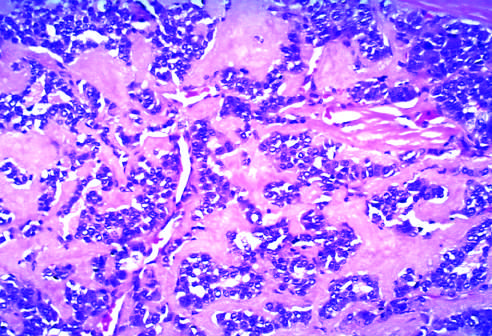what contain amyloid derived from calcitonin molecules secreted by the neoplastic cells?
Answer the question using a single word or phrase. Medullary carcinoma tumors 